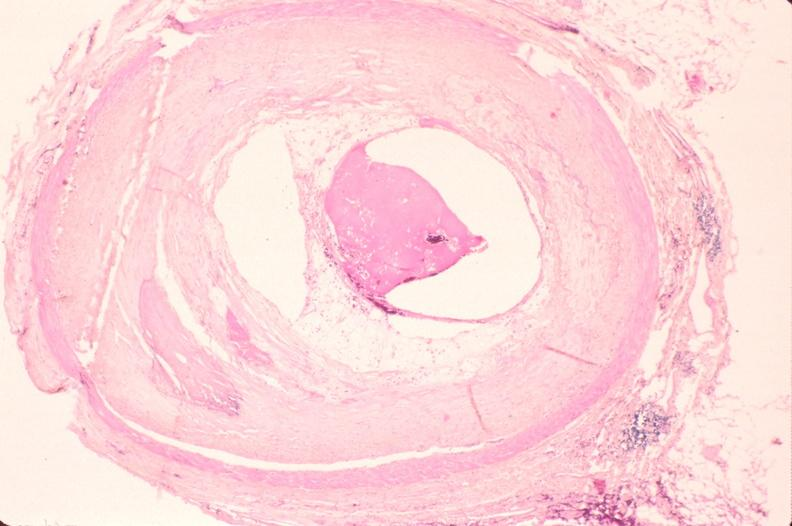what does this image show?
Answer the question using a single word or phrase. Atherosclerosis 